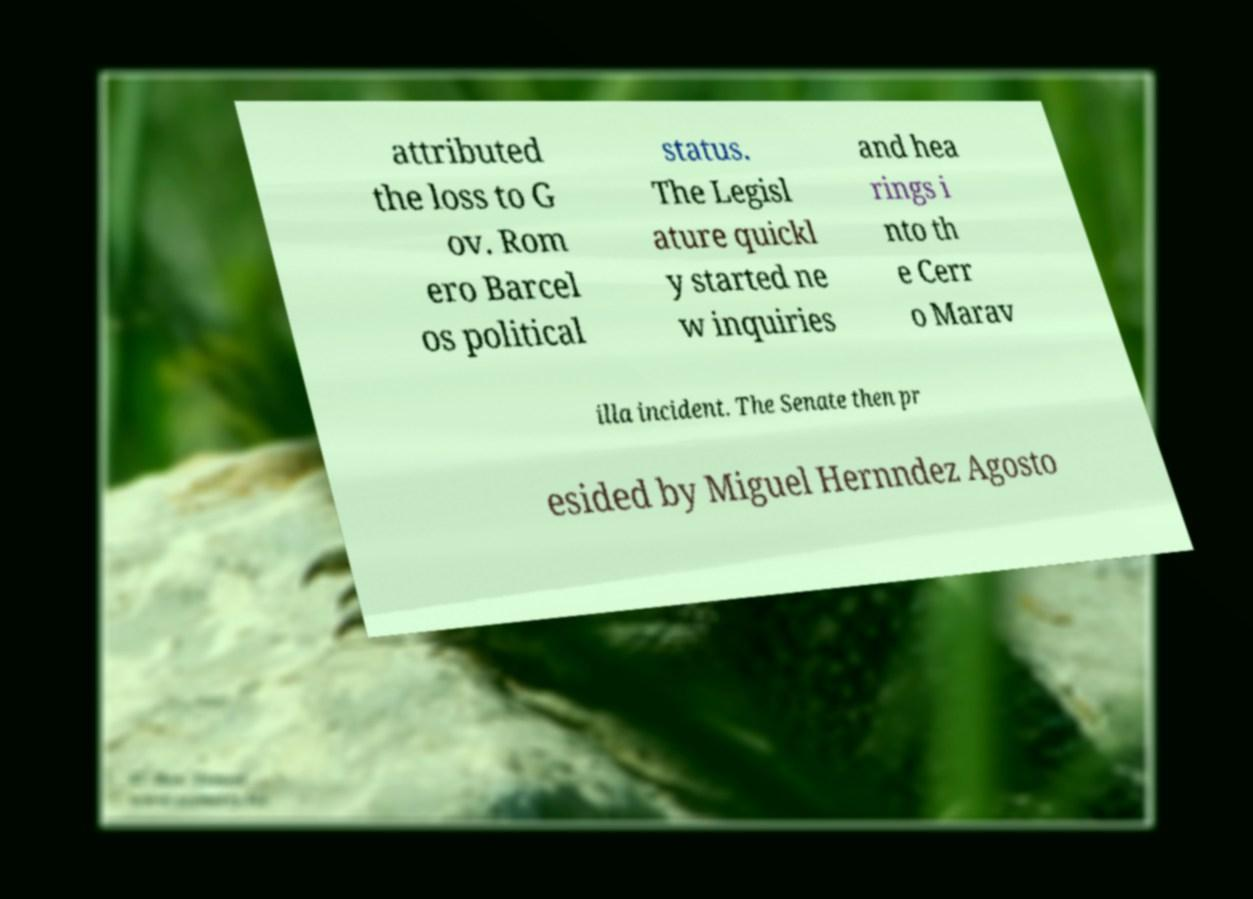Can you accurately transcribe the text from the provided image for me? attributed the loss to G ov. Rom ero Barcel os political status. The Legisl ature quickl y started ne w inquiries and hea rings i nto th e Cerr o Marav illa incident. The Senate then pr esided by Miguel Hernndez Agosto 